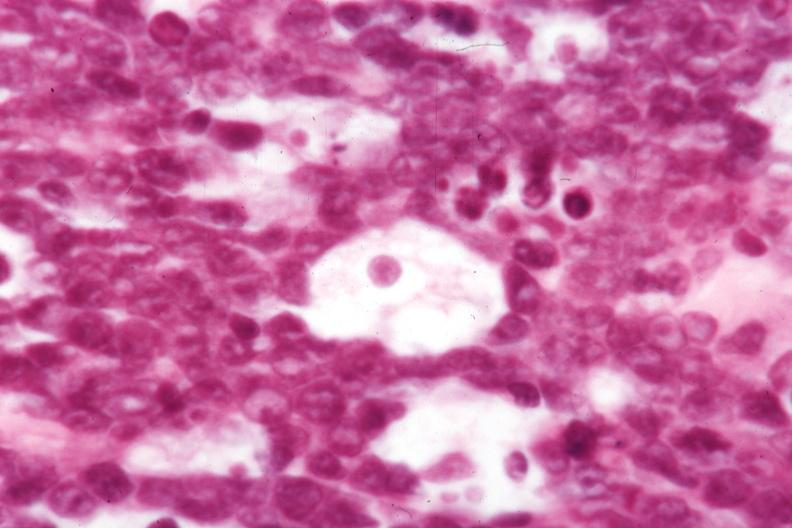what is present?
Answer the question using a single word or phrase. Lymph node 